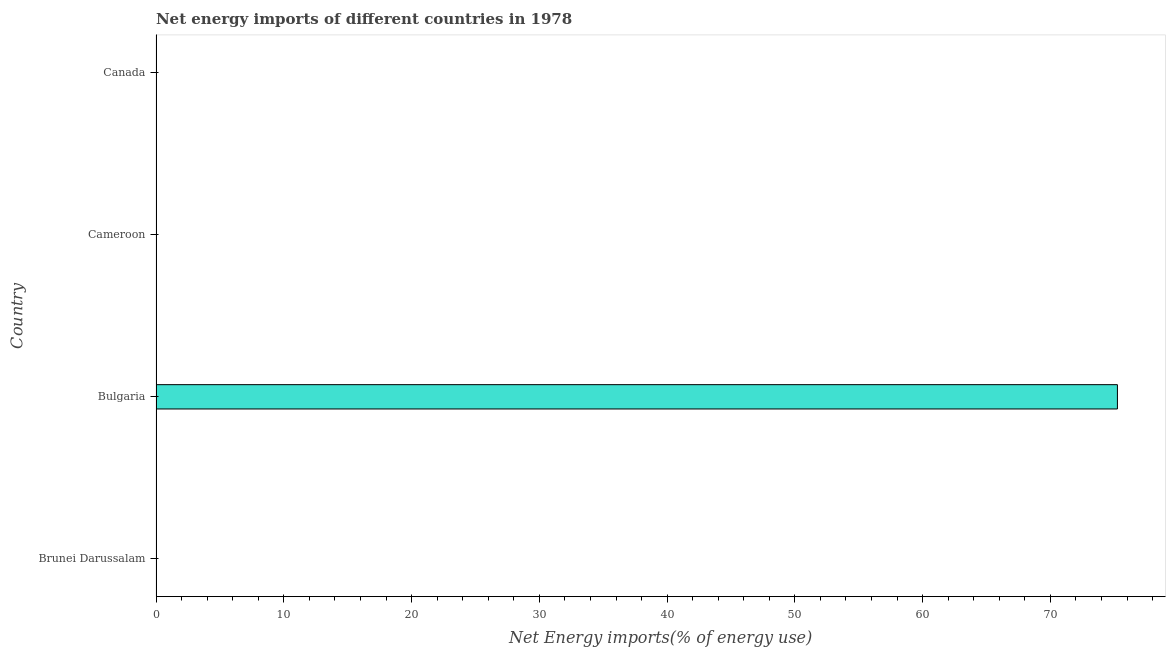Does the graph contain grids?
Offer a terse response. No. What is the title of the graph?
Make the answer very short. Net energy imports of different countries in 1978. What is the label or title of the X-axis?
Ensure brevity in your answer.  Net Energy imports(% of energy use). What is the label or title of the Y-axis?
Offer a terse response. Country. What is the energy imports in Canada?
Offer a terse response. 0. Across all countries, what is the maximum energy imports?
Give a very brief answer. 75.24. In which country was the energy imports maximum?
Provide a succinct answer. Bulgaria. What is the sum of the energy imports?
Provide a short and direct response. 75.24. What is the average energy imports per country?
Ensure brevity in your answer.  18.81. What is the median energy imports?
Your response must be concise. 0. In how many countries, is the energy imports greater than 10 %?
Your response must be concise. 1. What is the difference between the highest and the lowest energy imports?
Give a very brief answer. 75.24. How many countries are there in the graph?
Give a very brief answer. 4. What is the difference between two consecutive major ticks on the X-axis?
Provide a short and direct response. 10. What is the Net Energy imports(% of energy use) of Brunei Darussalam?
Your answer should be compact. 0. What is the Net Energy imports(% of energy use) of Bulgaria?
Your response must be concise. 75.24. What is the Net Energy imports(% of energy use) in Cameroon?
Offer a very short reply. 0. 